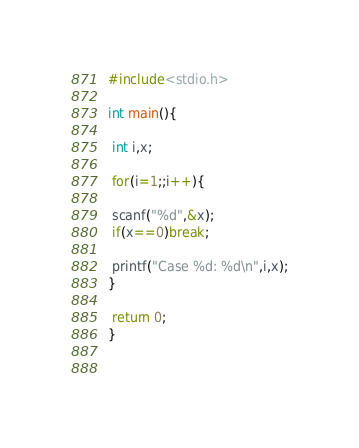Convert code to text. <code><loc_0><loc_0><loc_500><loc_500><_C_>#include<stdio.h>

int main(){

 int i,x;

 for(i=1;;i++){

 scanf("%d",&x);
 if(x==0)break;

 printf("Case %d: %d\n",i,x);
}

 return 0;
}
 
 
</code> 